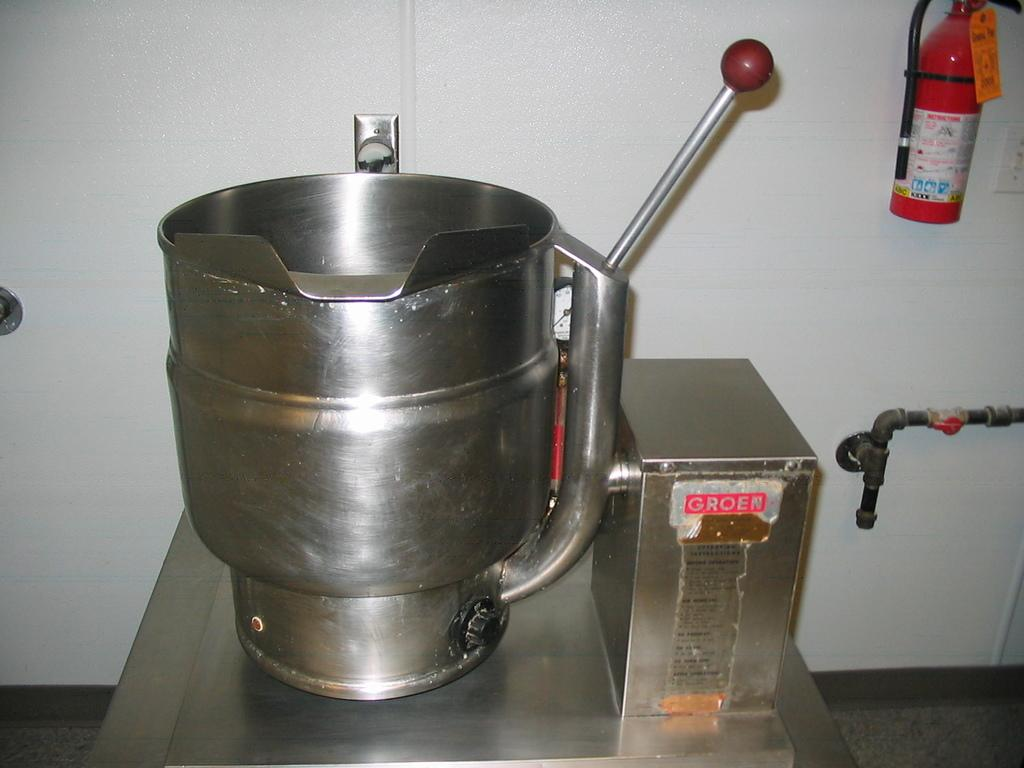<image>
Offer a succinct explanation of the picture presented. A metal box reads Groen in silver letters on a red background. 